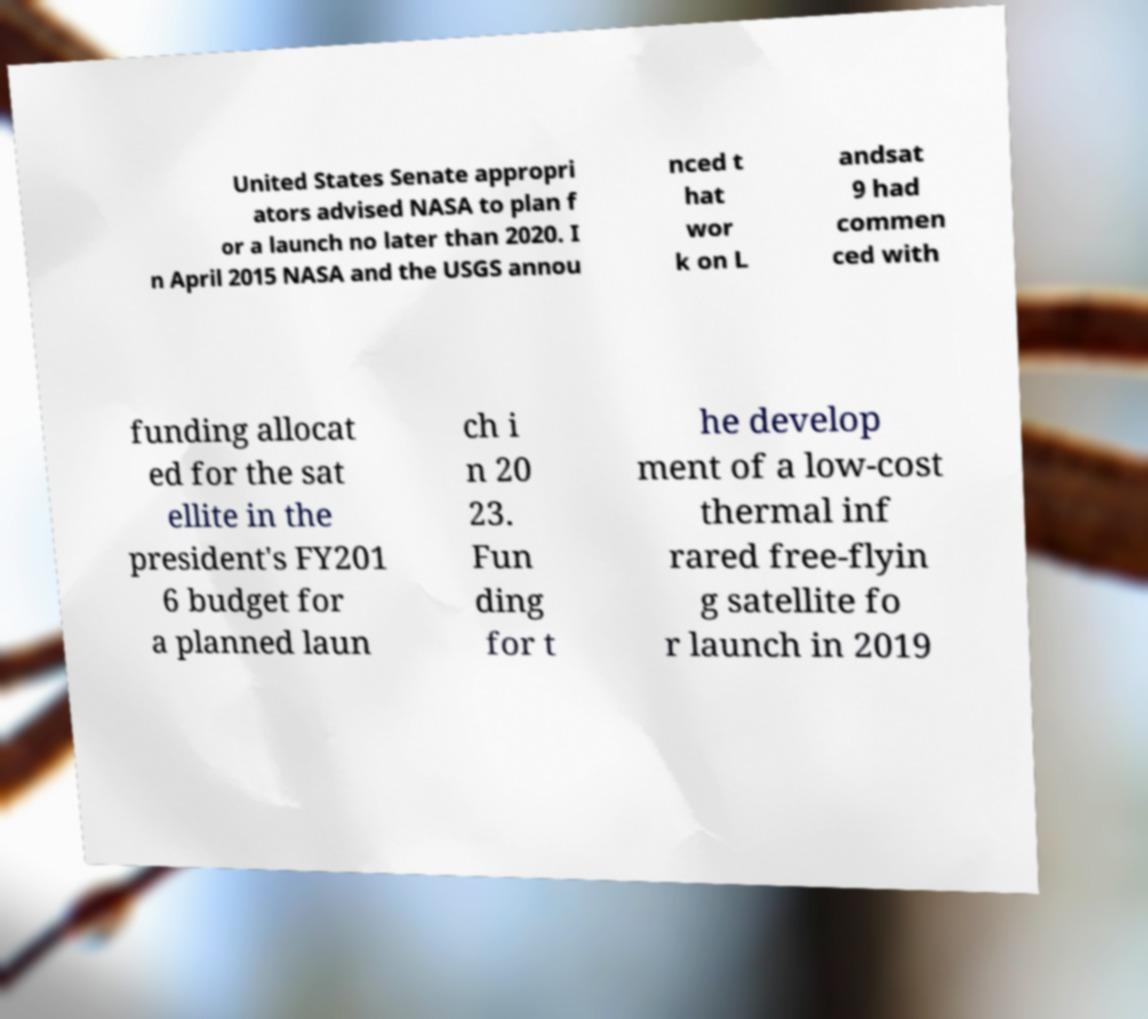Can you accurately transcribe the text from the provided image for me? United States Senate appropri ators advised NASA to plan f or a launch no later than 2020. I n April 2015 NASA and the USGS annou nced t hat wor k on L andsat 9 had commen ced with funding allocat ed for the sat ellite in the president's FY201 6 budget for a planned laun ch i n 20 23. Fun ding for t he develop ment of a low-cost thermal inf rared free-flyin g satellite fo r launch in 2019 